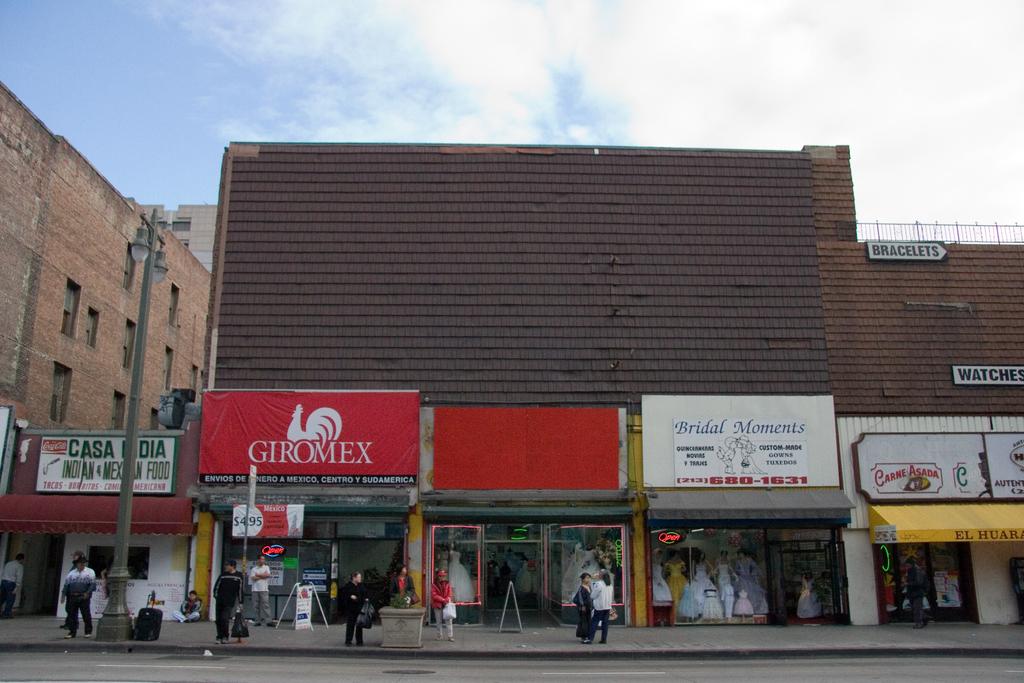What is the name of one of the stores?
Make the answer very short. Giromex. 